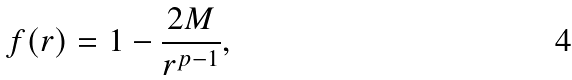Convert formula to latex. <formula><loc_0><loc_0><loc_500><loc_500>f ( r ) = 1 - \frac { 2 M } { r ^ { p - 1 } } ,</formula> 